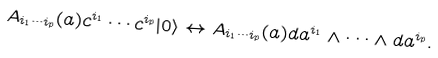<formula> <loc_0><loc_0><loc_500><loc_500>A _ { i _ { 1 } \cdots i _ { p } } ( a ) c ^ { i _ { 1 } } \cdots c ^ { i _ { p } } | 0 \rangle \leftrightarrow A _ { i _ { 1 } \cdots i _ { p } } ( a ) d a ^ { i _ { 1 } } \wedge \cdots \wedge d a ^ { i _ { p } } .</formula> 